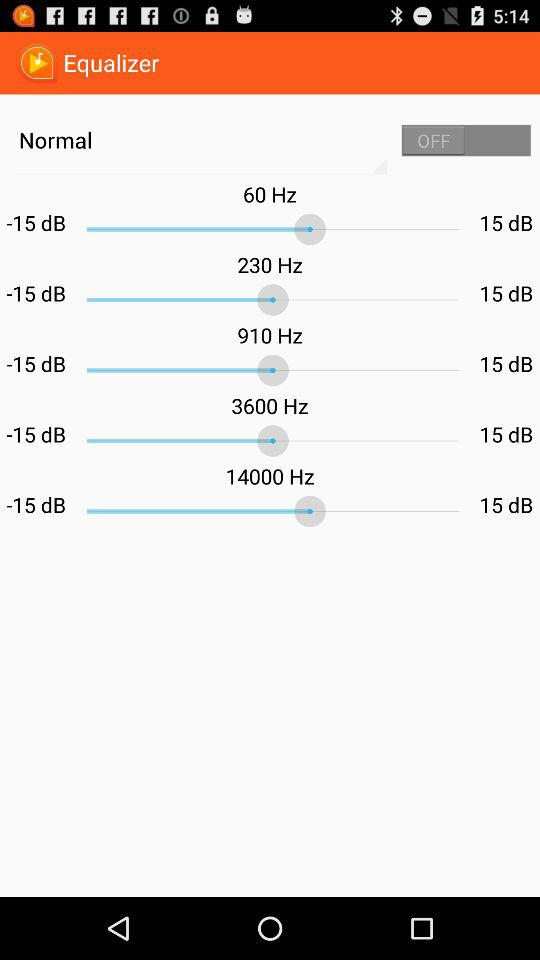What is the status of "Normal"? The status is "off". 